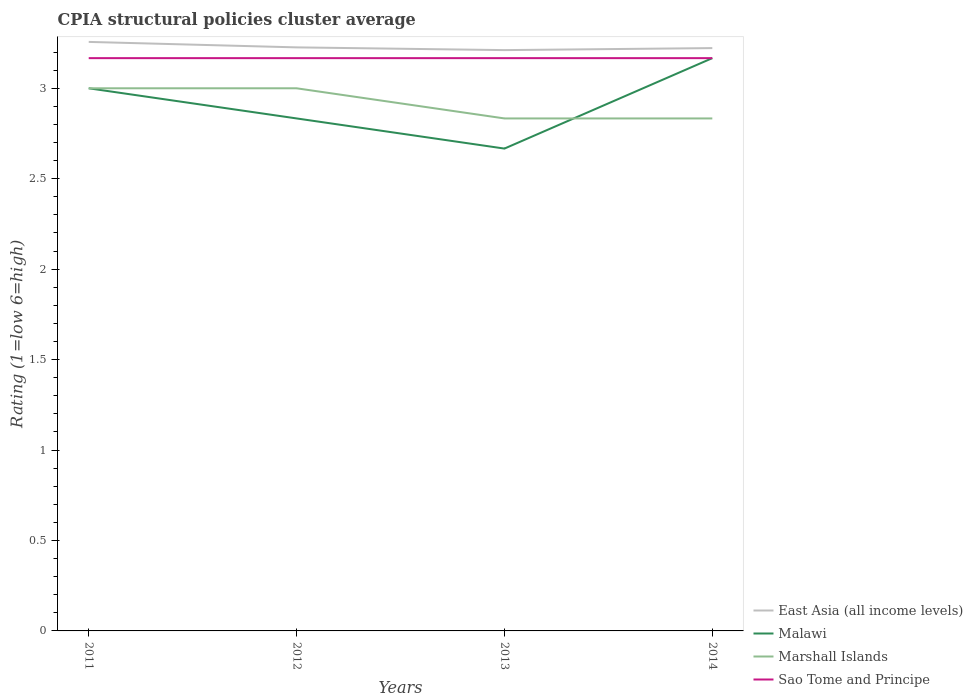How many different coloured lines are there?
Give a very brief answer. 4. Does the line corresponding to Malawi intersect with the line corresponding to Marshall Islands?
Offer a terse response. Yes. Is the number of lines equal to the number of legend labels?
Your response must be concise. Yes. Across all years, what is the maximum CPIA rating in Marshall Islands?
Your response must be concise. 2.83. In which year was the CPIA rating in East Asia (all income levels) maximum?
Offer a terse response. 2013. What is the difference between the highest and the second highest CPIA rating in East Asia (all income levels)?
Your response must be concise. 0.05. How many lines are there?
Offer a very short reply. 4. How many years are there in the graph?
Give a very brief answer. 4. Does the graph contain any zero values?
Ensure brevity in your answer.  No. Does the graph contain grids?
Your answer should be very brief. No. How many legend labels are there?
Provide a succinct answer. 4. What is the title of the graph?
Provide a succinct answer. CPIA structural policies cluster average. What is the label or title of the Y-axis?
Provide a succinct answer. Rating (1=low 6=high). What is the Rating (1=low 6=high) in East Asia (all income levels) in 2011?
Offer a terse response. 3.26. What is the Rating (1=low 6=high) in Malawi in 2011?
Provide a short and direct response. 3. What is the Rating (1=low 6=high) of Sao Tome and Principe in 2011?
Offer a very short reply. 3.17. What is the Rating (1=low 6=high) in East Asia (all income levels) in 2012?
Offer a very short reply. 3.23. What is the Rating (1=low 6=high) in Malawi in 2012?
Keep it short and to the point. 2.83. What is the Rating (1=low 6=high) in Marshall Islands in 2012?
Your response must be concise. 3. What is the Rating (1=low 6=high) in Sao Tome and Principe in 2012?
Your response must be concise. 3.17. What is the Rating (1=low 6=high) of East Asia (all income levels) in 2013?
Keep it short and to the point. 3.21. What is the Rating (1=low 6=high) of Malawi in 2013?
Your response must be concise. 2.67. What is the Rating (1=low 6=high) in Marshall Islands in 2013?
Your answer should be very brief. 2.83. What is the Rating (1=low 6=high) in Sao Tome and Principe in 2013?
Offer a terse response. 3.17. What is the Rating (1=low 6=high) of East Asia (all income levels) in 2014?
Offer a very short reply. 3.22. What is the Rating (1=low 6=high) of Malawi in 2014?
Make the answer very short. 3.17. What is the Rating (1=low 6=high) in Marshall Islands in 2014?
Ensure brevity in your answer.  2.83. What is the Rating (1=low 6=high) in Sao Tome and Principe in 2014?
Keep it short and to the point. 3.17. Across all years, what is the maximum Rating (1=low 6=high) in East Asia (all income levels)?
Keep it short and to the point. 3.26. Across all years, what is the maximum Rating (1=low 6=high) of Malawi?
Your answer should be compact. 3.17. Across all years, what is the maximum Rating (1=low 6=high) of Sao Tome and Principe?
Your answer should be compact. 3.17. Across all years, what is the minimum Rating (1=low 6=high) in East Asia (all income levels)?
Offer a terse response. 3.21. Across all years, what is the minimum Rating (1=low 6=high) of Malawi?
Provide a short and direct response. 2.67. Across all years, what is the minimum Rating (1=low 6=high) of Marshall Islands?
Your answer should be very brief. 2.83. Across all years, what is the minimum Rating (1=low 6=high) of Sao Tome and Principe?
Keep it short and to the point. 3.17. What is the total Rating (1=low 6=high) of East Asia (all income levels) in the graph?
Your answer should be very brief. 12.92. What is the total Rating (1=low 6=high) in Malawi in the graph?
Your response must be concise. 11.67. What is the total Rating (1=low 6=high) of Marshall Islands in the graph?
Keep it short and to the point. 11.67. What is the total Rating (1=low 6=high) in Sao Tome and Principe in the graph?
Your answer should be compact. 12.67. What is the difference between the Rating (1=low 6=high) in East Asia (all income levels) in 2011 and that in 2012?
Provide a short and direct response. 0.03. What is the difference between the Rating (1=low 6=high) of Sao Tome and Principe in 2011 and that in 2012?
Keep it short and to the point. 0. What is the difference between the Rating (1=low 6=high) of East Asia (all income levels) in 2011 and that in 2013?
Ensure brevity in your answer.  0.05. What is the difference between the Rating (1=low 6=high) of Malawi in 2011 and that in 2013?
Offer a terse response. 0.33. What is the difference between the Rating (1=low 6=high) in Marshall Islands in 2011 and that in 2013?
Your answer should be compact. 0.17. What is the difference between the Rating (1=low 6=high) of Sao Tome and Principe in 2011 and that in 2013?
Provide a succinct answer. 0. What is the difference between the Rating (1=low 6=high) in East Asia (all income levels) in 2011 and that in 2014?
Ensure brevity in your answer.  0.03. What is the difference between the Rating (1=low 6=high) in Sao Tome and Principe in 2011 and that in 2014?
Give a very brief answer. -0. What is the difference between the Rating (1=low 6=high) in East Asia (all income levels) in 2012 and that in 2013?
Give a very brief answer. 0.02. What is the difference between the Rating (1=low 6=high) of East Asia (all income levels) in 2012 and that in 2014?
Ensure brevity in your answer.  0. What is the difference between the Rating (1=low 6=high) in Malawi in 2012 and that in 2014?
Offer a very short reply. -0.33. What is the difference between the Rating (1=low 6=high) in East Asia (all income levels) in 2013 and that in 2014?
Your response must be concise. -0.01. What is the difference between the Rating (1=low 6=high) of Malawi in 2013 and that in 2014?
Ensure brevity in your answer.  -0.5. What is the difference between the Rating (1=low 6=high) of Sao Tome and Principe in 2013 and that in 2014?
Your answer should be very brief. -0. What is the difference between the Rating (1=low 6=high) of East Asia (all income levels) in 2011 and the Rating (1=low 6=high) of Malawi in 2012?
Provide a succinct answer. 0.42. What is the difference between the Rating (1=low 6=high) in East Asia (all income levels) in 2011 and the Rating (1=low 6=high) in Marshall Islands in 2012?
Offer a terse response. 0.26. What is the difference between the Rating (1=low 6=high) in East Asia (all income levels) in 2011 and the Rating (1=low 6=high) in Sao Tome and Principe in 2012?
Make the answer very short. 0.09. What is the difference between the Rating (1=low 6=high) of Malawi in 2011 and the Rating (1=low 6=high) of Marshall Islands in 2012?
Provide a short and direct response. 0. What is the difference between the Rating (1=low 6=high) in Malawi in 2011 and the Rating (1=low 6=high) in Sao Tome and Principe in 2012?
Keep it short and to the point. -0.17. What is the difference between the Rating (1=low 6=high) of East Asia (all income levels) in 2011 and the Rating (1=low 6=high) of Malawi in 2013?
Your response must be concise. 0.59. What is the difference between the Rating (1=low 6=high) of East Asia (all income levels) in 2011 and the Rating (1=low 6=high) of Marshall Islands in 2013?
Provide a short and direct response. 0.42. What is the difference between the Rating (1=low 6=high) in East Asia (all income levels) in 2011 and the Rating (1=low 6=high) in Sao Tome and Principe in 2013?
Offer a very short reply. 0.09. What is the difference between the Rating (1=low 6=high) in Malawi in 2011 and the Rating (1=low 6=high) in Marshall Islands in 2013?
Provide a short and direct response. 0.17. What is the difference between the Rating (1=low 6=high) of Malawi in 2011 and the Rating (1=low 6=high) of Sao Tome and Principe in 2013?
Your response must be concise. -0.17. What is the difference between the Rating (1=low 6=high) of East Asia (all income levels) in 2011 and the Rating (1=low 6=high) of Malawi in 2014?
Provide a short and direct response. 0.09. What is the difference between the Rating (1=low 6=high) of East Asia (all income levels) in 2011 and the Rating (1=low 6=high) of Marshall Islands in 2014?
Offer a terse response. 0.42. What is the difference between the Rating (1=low 6=high) of East Asia (all income levels) in 2011 and the Rating (1=low 6=high) of Sao Tome and Principe in 2014?
Offer a terse response. 0.09. What is the difference between the Rating (1=low 6=high) of East Asia (all income levels) in 2012 and the Rating (1=low 6=high) of Malawi in 2013?
Offer a very short reply. 0.56. What is the difference between the Rating (1=low 6=high) of East Asia (all income levels) in 2012 and the Rating (1=low 6=high) of Marshall Islands in 2013?
Give a very brief answer. 0.39. What is the difference between the Rating (1=low 6=high) in East Asia (all income levels) in 2012 and the Rating (1=low 6=high) in Sao Tome and Principe in 2013?
Keep it short and to the point. 0.06. What is the difference between the Rating (1=low 6=high) in Malawi in 2012 and the Rating (1=low 6=high) in Marshall Islands in 2013?
Provide a short and direct response. 0. What is the difference between the Rating (1=low 6=high) in Malawi in 2012 and the Rating (1=low 6=high) in Sao Tome and Principe in 2013?
Keep it short and to the point. -0.33. What is the difference between the Rating (1=low 6=high) in East Asia (all income levels) in 2012 and the Rating (1=low 6=high) in Malawi in 2014?
Keep it short and to the point. 0.06. What is the difference between the Rating (1=low 6=high) in East Asia (all income levels) in 2012 and the Rating (1=low 6=high) in Marshall Islands in 2014?
Provide a succinct answer. 0.39. What is the difference between the Rating (1=low 6=high) in East Asia (all income levels) in 2012 and the Rating (1=low 6=high) in Sao Tome and Principe in 2014?
Give a very brief answer. 0.06. What is the difference between the Rating (1=low 6=high) in Malawi in 2012 and the Rating (1=low 6=high) in Marshall Islands in 2014?
Keep it short and to the point. 0. What is the difference between the Rating (1=low 6=high) in Marshall Islands in 2012 and the Rating (1=low 6=high) in Sao Tome and Principe in 2014?
Ensure brevity in your answer.  -0.17. What is the difference between the Rating (1=low 6=high) of East Asia (all income levels) in 2013 and the Rating (1=low 6=high) of Malawi in 2014?
Provide a short and direct response. 0.04. What is the difference between the Rating (1=low 6=high) in East Asia (all income levels) in 2013 and the Rating (1=low 6=high) in Marshall Islands in 2014?
Make the answer very short. 0.38. What is the difference between the Rating (1=low 6=high) in East Asia (all income levels) in 2013 and the Rating (1=low 6=high) in Sao Tome and Principe in 2014?
Provide a short and direct response. 0.04. What is the difference between the Rating (1=low 6=high) of Malawi in 2013 and the Rating (1=low 6=high) of Marshall Islands in 2014?
Give a very brief answer. -0.17. What is the difference between the Rating (1=low 6=high) in Marshall Islands in 2013 and the Rating (1=low 6=high) in Sao Tome and Principe in 2014?
Offer a terse response. -0.33. What is the average Rating (1=low 6=high) of East Asia (all income levels) per year?
Your response must be concise. 3.23. What is the average Rating (1=low 6=high) of Malawi per year?
Provide a short and direct response. 2.92. What is the average Rating (1=low 6=high) of Marshall Islands per year?
Give a very brief answer. 2.92. What is the average Rating (1=low 6=high) in Sao Tome and Principe per year?
Ensure brevity in your answer.  3.17. In the year 2011, what is the difference between the Rating (1=low 6=high) in East Asia (all income levels) and Rating (1=low 6=high) in Malawi?
Keep it short and to the point. 0.26. In the year 2011, what is the difference between the Rating (1=low 6=high) in East Asia (all income levels) and Rating (1=low 6=high) in Marshall Islands?
Offer a terse response. 0.26. In the year 2011, what is the difference between the Rating (1=low 6=high) of East Asia (all income levels) and Rating (1=low 6=high) of Sao Tome and Principe?
Ensure brevity in your answer.  0.09. In the year 2011, what is the difference between the Rating (1=low 6=high) in Malawi and Rating (1=low 6=high) in Marshall Islands?
Give a very brief answer. 0. In the year 2011, what is the difference between the Rating (1=low 6=high) of Malawi and Rating (1=low 6=high) of Sao Tome and Principe?
Provide a short and direct response. -0.17. In the year 2011, what is the difference between the Rating (1=low 6=high) in Marshall Islands and Rating (1=low 6=high) in Sao Tome and Principe?
Your response must be concise. -0.17. In the year 2012, what is the difference between the Rating (1=low 6=high) in East Asia (all income levels) and Rating (1=low 6=high) in Malawi?
Give a very brief answer. 0.39. In the year 2012, what is the difference between the Rating (1=low 6=high) of East Asia (all income levels) and Rating (1=low 6=high) of Marshall Islands?
Ensure brevity in your answer.  0.23. In the year 2012, what is the difference between the Rating (1=low 6=high) of East Asia (all income levels) and Rating (1=low 6=high) of Sao Tome and Principe?
Provide a short and direct response. 0.06. In the year 2012, what is the difference between the Rating (1=low 6=high) in Malawi and Rating (1=low 6=high) in Marshall Islands?
Make the answer very short. -0.17. In the year 2013, what is the difference between the Rating (1=low 6=high) of East Asia (all income levels) and Rating (1=low 6=high) of Malawi?
Offer a very short reply. 0.54. In the year 2013, what is the difference between the Rating (1=low 6=high) of East Asia (all income levels) and Rating (1=low 6=high) of Marshall Islands?
Your response must be concise. 0.38. In the year 2013, what is the difference between the Rating (1=low 6=high) in East Asia (all income levels) and Rating (1=low 6=high) in Sao Tome and Principe?
Your answer should be very brief. 0.04. In the year 2014, what is the difference between the Rating (1=low 6=high) in East Asia (all income levels) and Rating (1=low 6=high) in Malawi?
Provide a short and direct response. 0.06. In the year 2014, what is the difference between the Rating (1=low 6=high) in East Asia (all income levels) and Rating (1=low 6=high) in Marshall Islands?
Offer a very short reply. 0.39. In the year 2014, what is the difference between the Rating (1=low 6=high) of East Asia (all income levels) and Rating (1=low 6=high) of Sao Tome and Principe?
Keep it short and to the point. 0.06. What is the ratio of the Rating (1=low 6=high) of East Asia (all income levels) in 2011 to that in 2012?
Your answer should be very brief. 1.01. What is the ratio of the Rating (1=low 6=high) of Malawi in 2011 to that in 2012?
Keep it short and to the point. 1.06. What is the ratio of the Rating (1=low 6=high) of Marshall Islands in 2011 to that in 2012?
Offer a terse response. 1. What is the ratio of the Rating (1=low 6=high) in East Asia (all income levels) in 2011 to that in 2013?
Your answer should be very brief. 1.01. What is the ratio of the Rating (1=low 6=high) of Malawi in 2011 to that in 2013?
Your response must be concise. 1.12. What is the ratio of the Rating (1=low 6=high) of Marshall Islands in 2011 to that in 2013?
Provide a succinct answer. 1.06. What is the ratio of the Rating (1=low 6=high) in Sao Tome and Principe in 2011 to that in 2013?
Keep it short and to the point. 1. What is the ratio of the Rating (1=low 6=high) in East Asia (all income levels) in 2011 to that in 2014?
Provide a succinct answer. 1.01. What is the ratio of the Rating (1=low 6=high) of Malawi in 2011 to that in 2014?
Provide a short and direct response. 0.95. What is the ratio of the Rating (1=low 6=high) in Marshall Islands in 2011 to that in 2014?
Provide a succinct answer. 1.06. What is the ratio of the Rating (1=low 6=high) of East Asia (all income levels) in 2012 to that in 2013?
Ensure brevity in your answer.  1. What is the ratio of the Rating (1=low 6=high) of Marshall Islands in 2012 to that in 2013?
Your answer should be very brief. 1.06. What is the ratio of the Rating (1=low 6=high) of Malawi in 2012 to that in 2014?
Give a very brief answer. 0.89. What is the ratio of the Rating (1=low 6=high) of Marshall Islands in 2012 to that in 2014?
Your answer should be compact. 1.06. What is the ratio of the Rating (1=low 6=high) of Sao Tome and Principe in 2012 to that in 2014?
Your answer should be compact. 1. What is the ratio of the Rating (1=low 6=high) of East Asia (all income levels) in 2013 to that in 2014?
Offer a terse response. 1. What is the ratio of the Rating (1=low 6=high) in Malawi in 2013 to that in 2014?
Your response must be concise. 0.84. What is the ratio of the Rating (1=low 6=high) in Marshall Islands in 2013 to that in 2014?
Your response must be concise. 1. What is the difference between the highest and the second highest Rating (1=low 6=high) in East Asia (all income levels)?
Provide a short and direct response. 0.03. What is the difference between the highest and the second highest Rating (1=low 6=high) in Marshall Islands?
Offer a terse response. 0. What is the difference between the highest and the second highest Rating (1=low 6=high) of Sao Tome and Principe?
Ensure brevity in your answer.  0. What is the difference between the highest and the lowest Rating (1=low 6=high) in East Asia (all income levels)?
Make the answer very short. 0.05. What is the difference between the highest and the lowest Rating (1=low 6=high) in Malawi?
Your answer should be compact. 0.5. What is the difference between the highest and the lowest Rating (1=low 6=high) of Marshall Islands?
Offer a terse response. 0.17. What is the difference between the highest and the lowest Rating (1=low 6=high) of Sao Tome and Principe?
Your response must be concise. 0. 